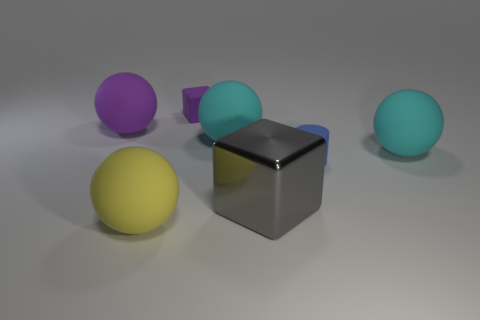Add 3 small blue blocks. How many objects exist? 10 Subtract all balls. How many objects are left? 3 Add 2 tiny purple objects. How many tiny purple objects are left? 3 Add 6 tiny green matte blocks. How many tiny green matte blocks exist? 6 Subtract 0 cyan blocks. How many objects are left? 7 Subtract all large yellow shiny cylinders. Subtract all tiny cubes. How many objects are left? 6 